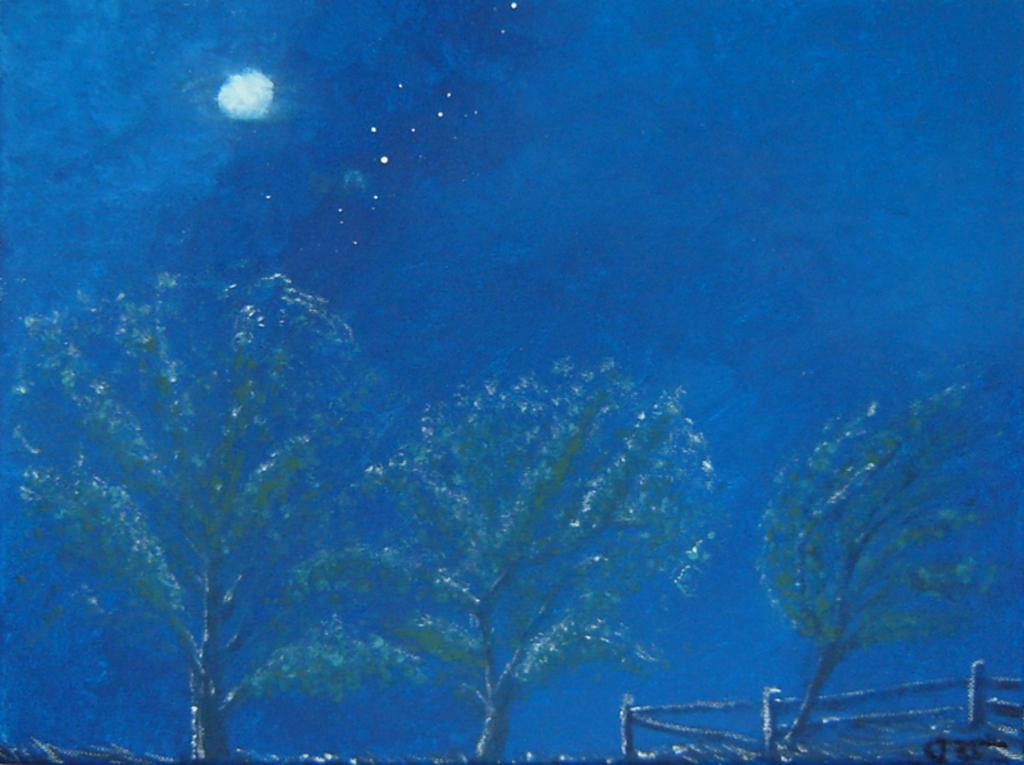What is the main subject of the painting in the image? The main subject of the painting in the image is trees. What celestial objects are included in the painting? The painting includes a depiction of the moon and stars. What part of the sky is depicted in the painting? The painting includes a depiction of the sky. What is the aftermath of the love depicted in the painting? There is no depiction of love in the painting; it features trees, the moon, stars, and the sky. 